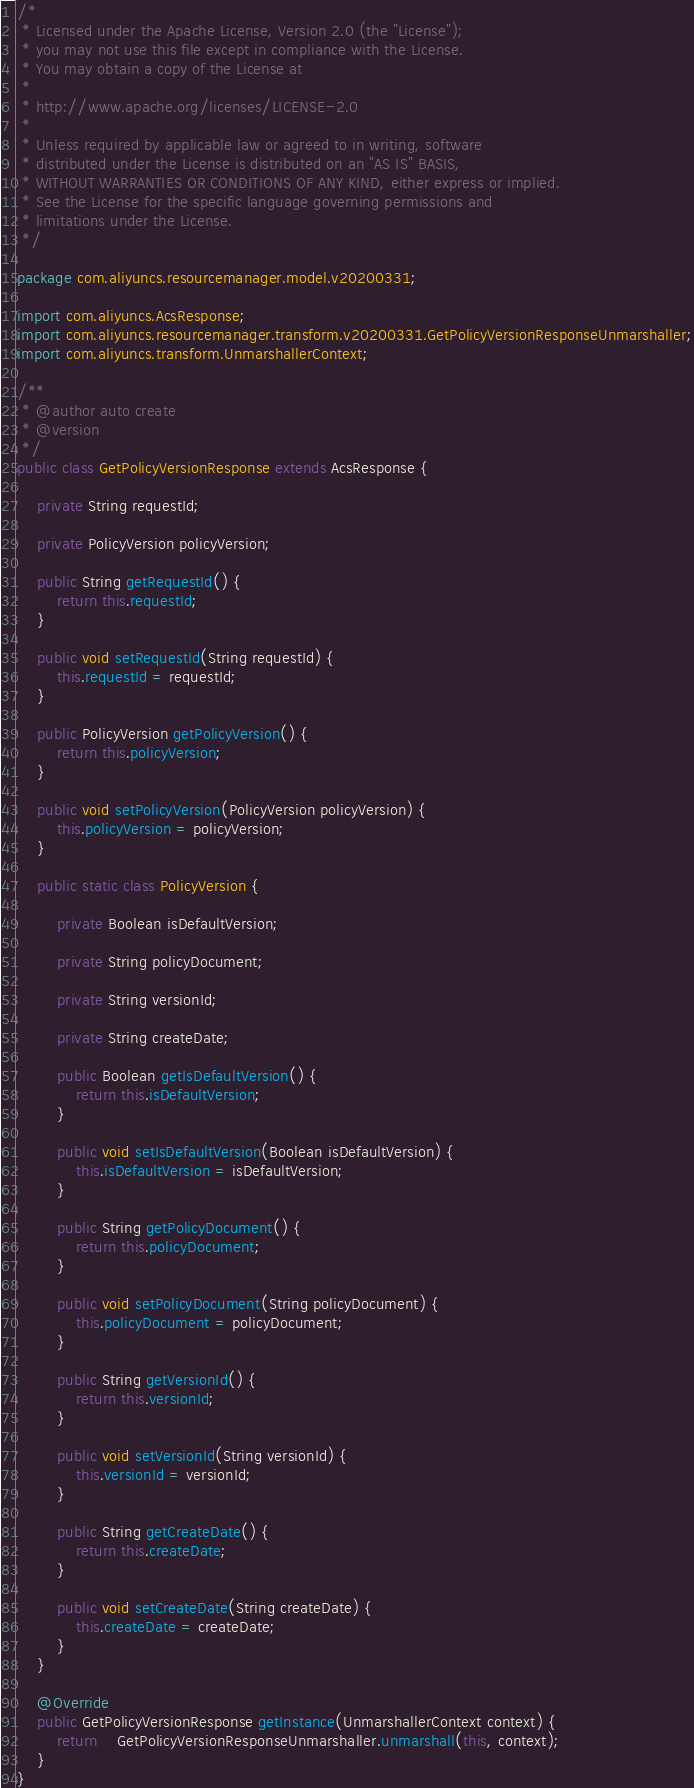<code> <loc_0><loc_0><loc_500><loc_500><_Java_>/*
 * Licensed under the Apache License, Version 2.0 (the "License");
 * you may not use this file except in compliance with the License.
 * You may obtain a copy of the License at
 *
 * http://www.apache.org/licenses/LICENSE-2.0
 *
 * Unless required by applicable law or agreed to in writing, software
 * distributed under the License is distributed on an "AS IS" BASIS,
 * WITHOUT WARRANTIES OR CONDITIONS OF ANY KIND, either express or implied.
 * See the License for the specific language governing permissions and
 * limitations under the License.
 */

package com.aliyuncs.resourcemanager.model.v20200331;

import com.aliyuncs.AcsResponse;
import com.aliyuncs.resourcemanager.transform.v20200331.GetPolicyVersionResponseUnmarshaller;
import com.aliyuncs.transform.UnmarshallerContext;

/**
 * @author auto create
 * @version 
 */
public class GetPolicyVersionResponse extends AcsResponse {

	private String requestId;

	private PolicyVersion policyVersion;

	public String getRequestId() {
		return this.requestId;
	}

	public void setRequestId(String requestId) {
		this.requestId = requestId;
	}

	public PolicyVersion getPolicyVersion() {
		return this.policyVersion;
	}

	public void setPolicyVersion(PolicyVersion policyVersion) {
		this.policyVersion = policyVersion;
	}

	public static class PolicyVersion {

		private Boolean isDefaultVersion;

		private String policyDocument;

		private String versionId;

		private String createDate;

		public Boolean getIsDefaultVersion() {
			return this.isDefaultVersion;
		}

		public void setIsDefaultVersion(Boolean isDefaultVersion) {
			this.isDefaultVersion = isDefaultVersion;
		}

		public String getPolicyDocument() {
			return this.policyDocument;
		}

		public void setPolicyDocument(String policyDocument) {
			this.policyDocument = policyDocument;
		}

		public String getVersionId() {
			return this.versionId;
		}

		public void setVersionId(String versionId) {
			this.versionId = versionId;
		}

		public String getCreateDate() {
			return this.createDate;
		}

		public void setCreateDate(String createDate) {
			this.createDate = createDate;
		}
	}

	@Override
	public GetPolicyVersionResponse getInstance(UnmarshallerContext context) {
		return	GetPolicyVersionResponseUnmarshaller.unmarshall(this, context);
	}
}
</code> 